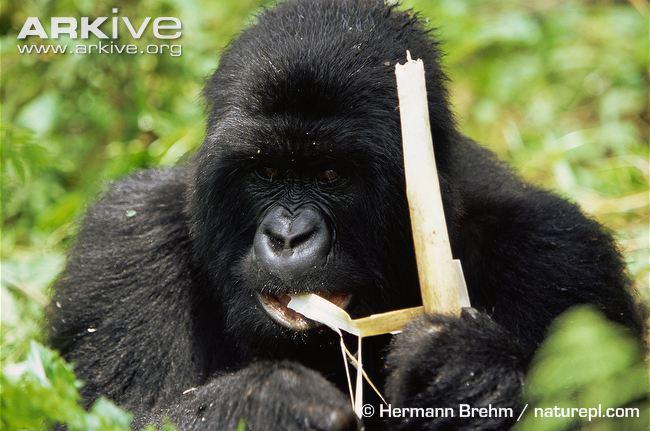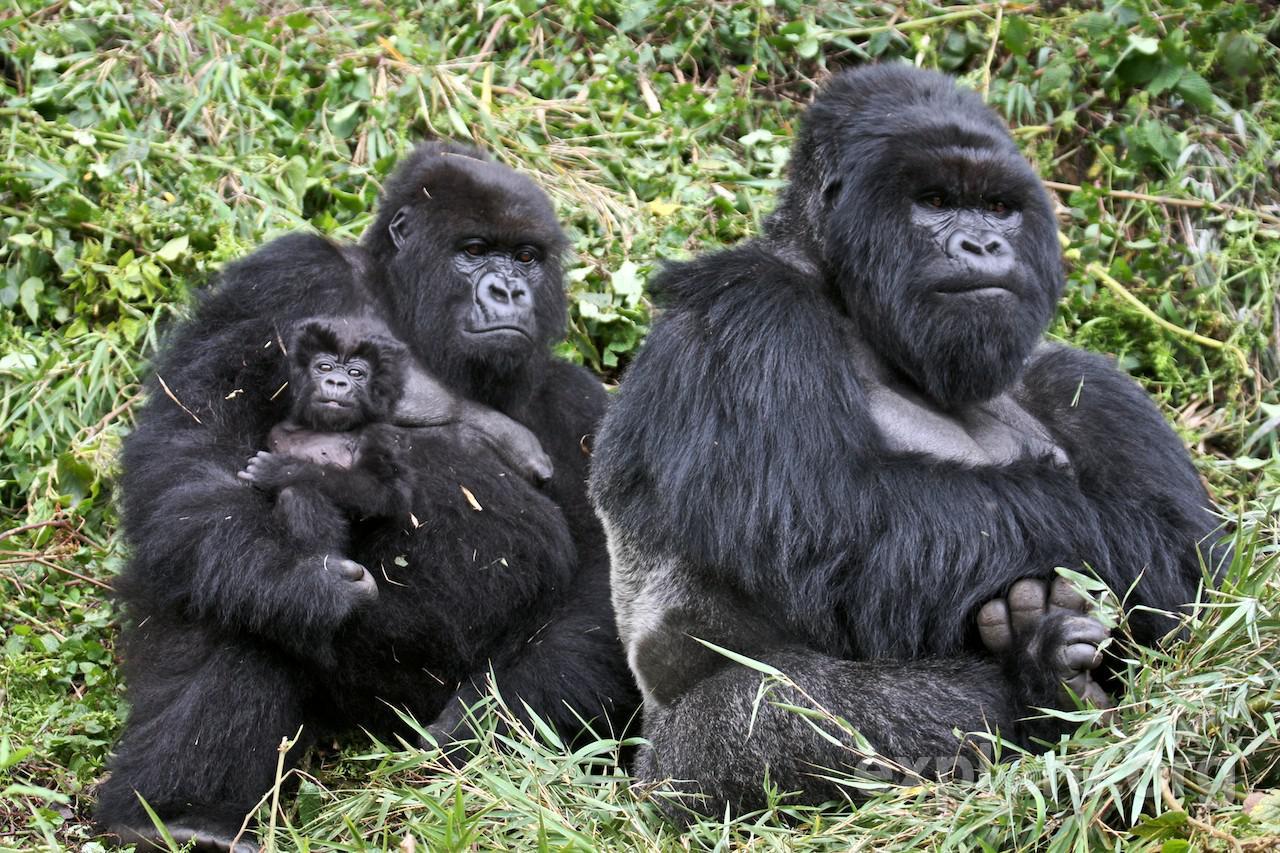The first image is the image on the left, the second image is the image on the right. For the images displayed, is the sentence "At least one person is present with an ape in one of the images." factually correct? Answer yes or no. No. 